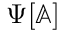Convert formula to latex. <formula><loc_0><loc_0><loc_500><loc_500>\Psi [ \mathbb { A } ]</formula> 